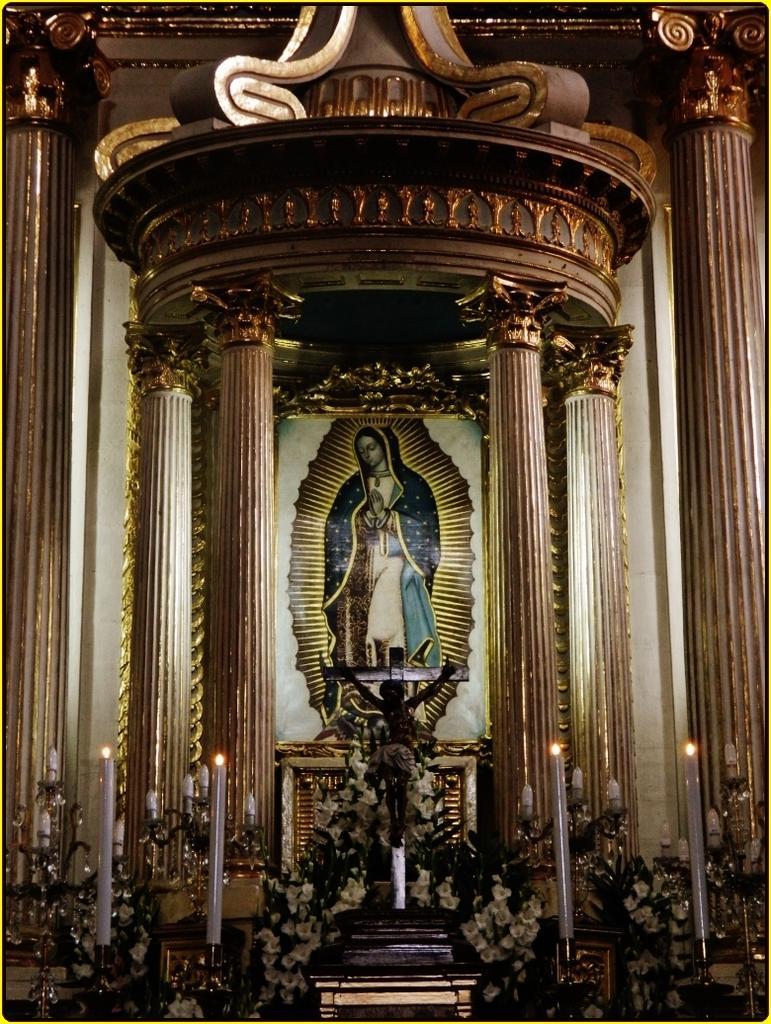Please provide a concise description of this image. In this image, we can see a cross and some flowers in between candles. There is an art in the middle of the image. There are pillars on the left and on the right side of the image. 